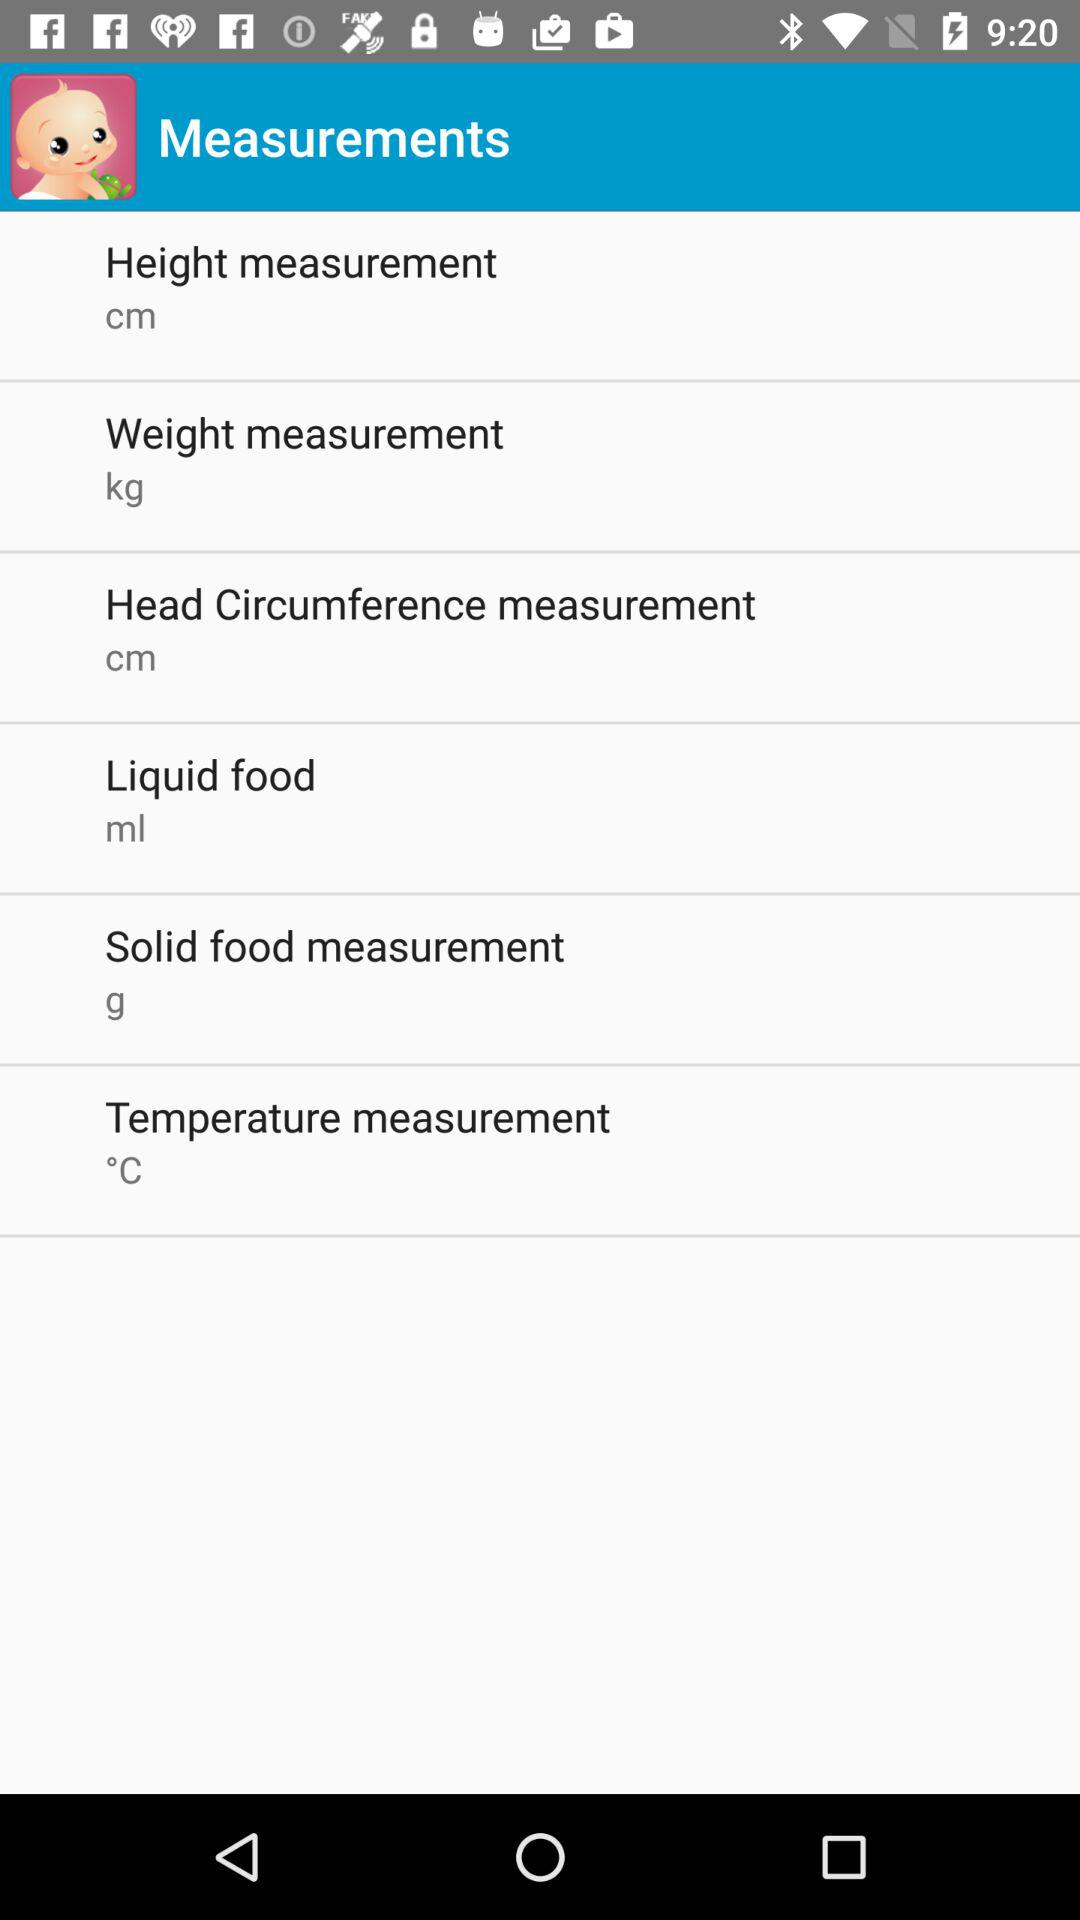What's the unit of weight measurement? The unit is kg. 